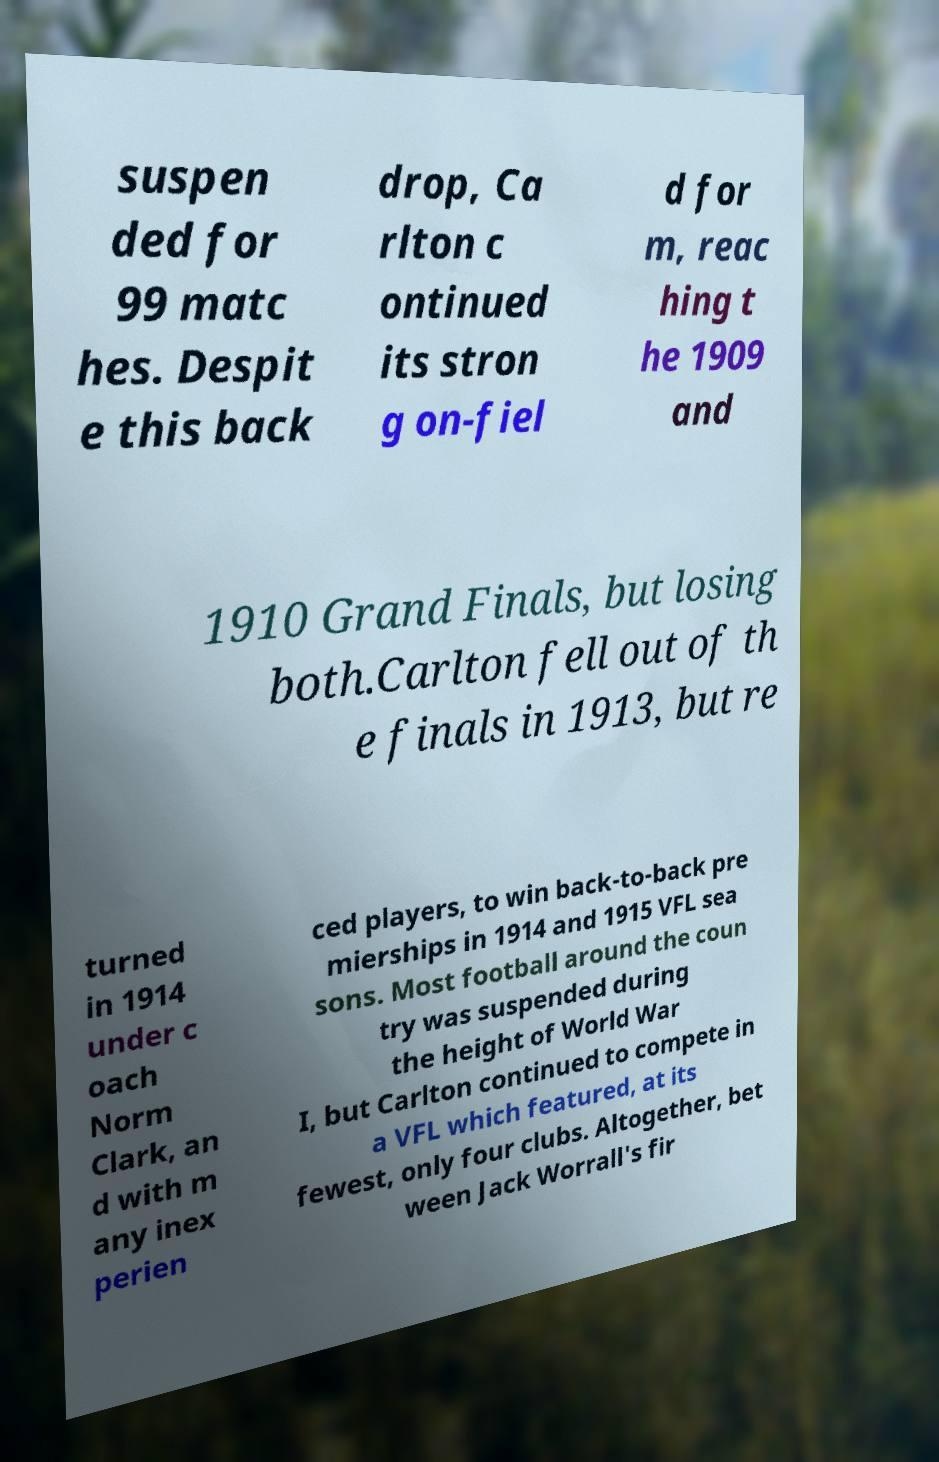Can you read and provide the text displayed in the image?This photo seems to have some interesting text. Can you extract and type it out for me? suspen ded for 99 matc hes. Despit e this back drop, Ca rlton c ontinued its stron g on-fiel d for m, reac hing t he 1909 and 1910 Grand Finals, but losing both.Carlton fell out of th e finals in 1913, but re turned in 1914 under c oach Norm Clark, an d with m any inex perien ced players, to win back-to-back pre mierships in 1914 and 1915 VFL sea sons. Most football around the coun try was suspended during the height of World War I, but Carlton continued to compete in a VFL which featured, at its fewest, only four clubs. Altogether, bet ween Jack Worrall's fir 